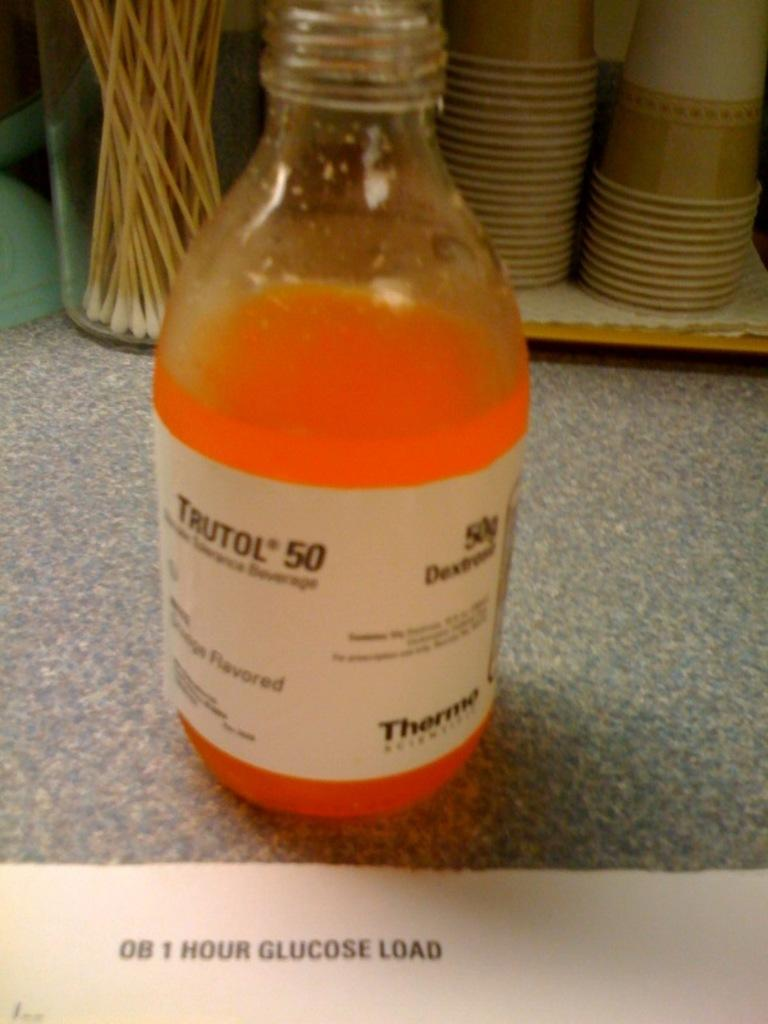<image>
Summarize the visual content of the image. A bottle of orange liquid has a label reading Trutol 50. 